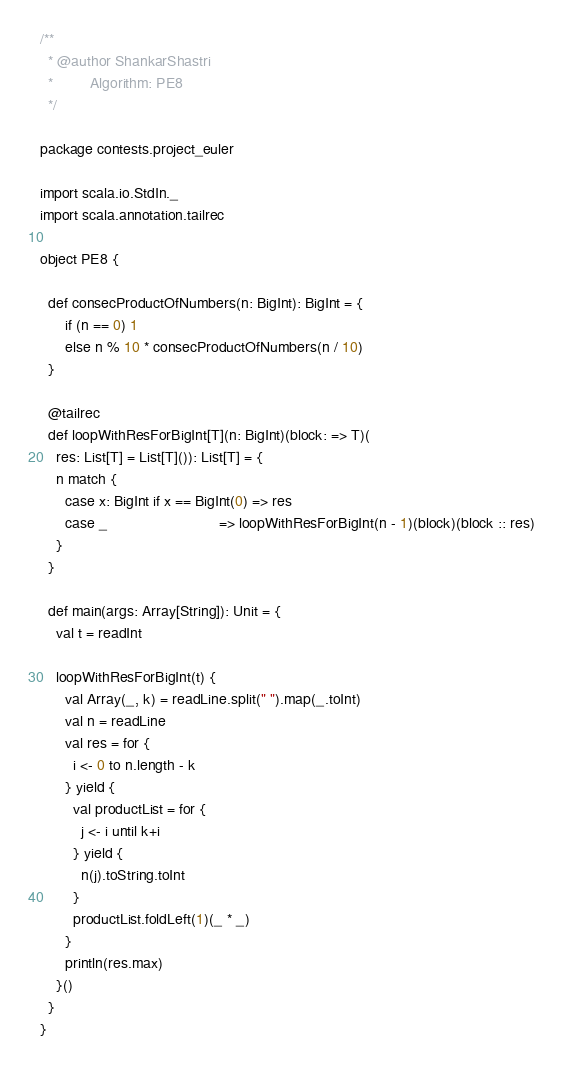Convert code to text. <code><loc_0><loc_0><loc_500><loc_500><_Scala_>/**
  * @author ShankarShastri
  *         Algorithm: PE8
  */

package contests.project_euler

import scala.io.StdIn._
import scala.annotation.tailrec

object PE8 {
  
  def consecProductOfNumbers(n: BigInt): BigInt = {
      if (n == 0) 1
      else n % 10 * consecProductOfNumbers(n / 10)
  }
  
  @tailrec
  def loopWithResForBigInt[T](n: BigInt)(block: => T)(
    res: List[T] = List[T]()): List[T] = {
    n match {
      case x: BigInt if x == BigInt(0) => res
      case _                           => loopWithResForBigInt(n - 1)(block)(block :: res)
    }
  }
  
  def main(args: Array[String]): Unit = {
    val t = readInt
  
    loopWithResForBigInt(t) {
      val Array(_, k) = readLine.split(" ").map(_.toInt)
      val n = readLine
      val res = for {
        i <- 0 to n.length - k
      } yield {
        val productList = for {
          j <- i until k+i
        } yield {
          n(j).toString.toInt
        }
        productList.foldLeft(1)(_ * _)
      }
      println(res.max)
    }()
  }
}
</code> 